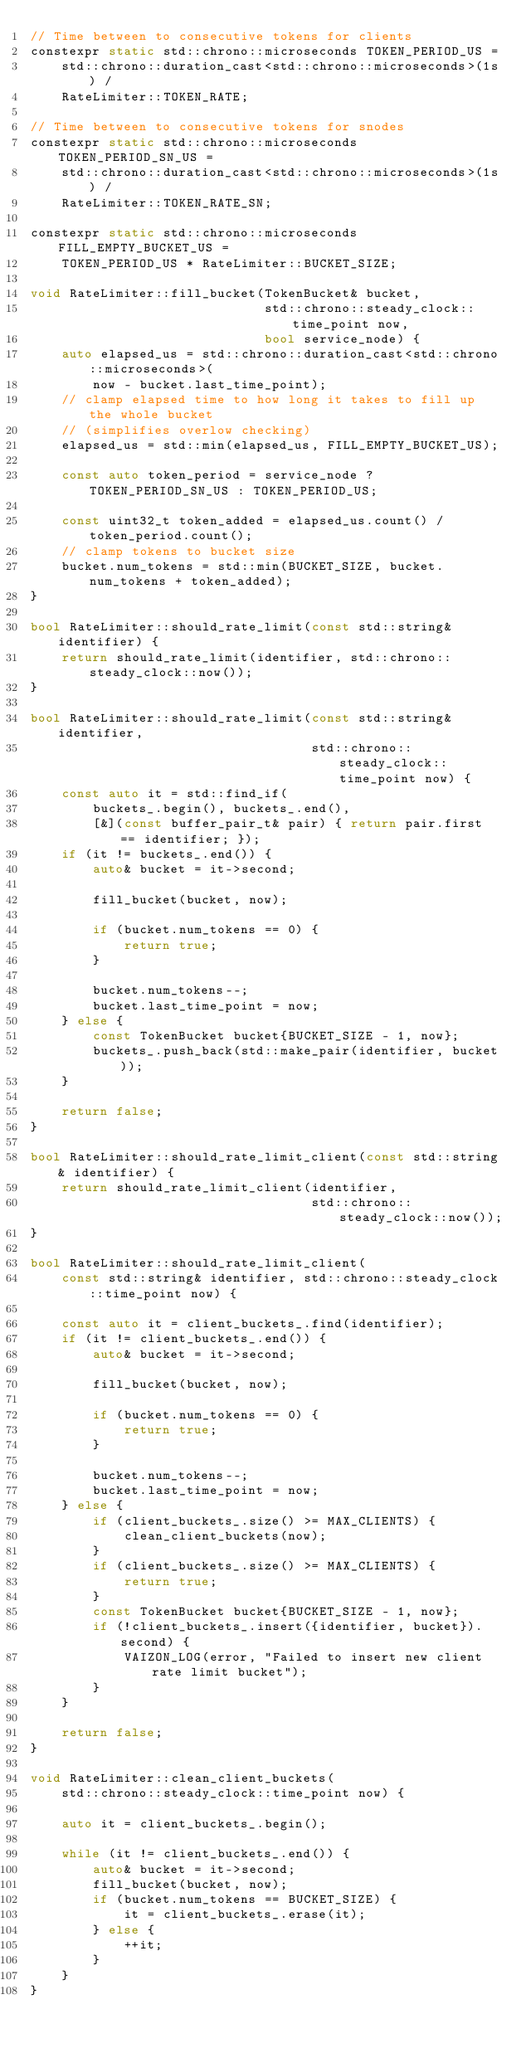Convert code to text. <code><loc_0><loc_0><loc_500><loc_500><_C++_>// Time between to consecutive tokens for clients
constexpr static std::chrono::microseconds TOKEN_PERIOD_US =
    std::chrono::duration_cast<std::chrono::microseconds>(1s) /
    RateLimiter::TOKEN_RATE;

// Time between to consecutive tokens for snodes
constexpr static std::chrono::microseconds TOKEN_PERIOD_SN_US =
    std::chrono::duration_cast<std::chrono::microseconds>(1s) /
    RateLimiter::TOKEN_RATE_SN;

constexpr static std::chrono::microseconds FILL_EMPTY_BUCKET_US =
    TOKEN_PERIOD_US * RateLimiter::BUCKET_SIZE;

void RateLimiter::fill_bucket(TokenBucket& bucket,
                              std::chrono::steady_clock::time_point now,
                              bool service_node) {
    auto elapsed_us = std::chrono::duration_cast<std::chrono::microseconds>(
        now - bucket.last_time_point);
    // clamp elapsed time to how long it takes to fill up the whole bucket
    // (simplifies overlow checking)
    elapsed_us = std::min(elapsed_us, FILL_EMPTY_BUCKET_US);

    const auto token_period = service_node ? TOKEN_PERIOD_SN_US : TOKEN_PERIOD_US;

    const uint32_t token_added = elapsed_us.count() / token_period.count();
    // clamp tokens to bucket size
    bucket.num_tokens = std::min(BUCKET_SIZE, bucket.num_tokens + token_added);
}

bool RateLimiter::should_rate_limit(const std::string& identifier) {
    return should_rate_limit(identifier, std::chrono::steady_clock::now());
}

bool RateLimiter::should_rate_limit(const std::string& identifier,
                                    std::chrono::steady_clock::time_point now) {
    const auto it = std::find_if(
        buckets_.begin(), buckets_.end(),
        [&](const buffer_pair_t& pair) { return pair.first == identifier; });
    if (it != buckets_.end()) {
        auto& bucket = it->second;

        fill_bucket(bucket, now);

        if (bucket.num_tokens == 0) {
            return true;
        }

        bucket.num_tokens--;
        bucket.last_time_point = now;
    } else {
        const TokenBucket bucket{BUCKET_SIZE - 1, now};
        buckets_.push_back(std::make_pair(identifier, bucket));
    }

    return false;
}

bool RateLimiter::should_rate_limit_client(const std::string& identifier) {
    return should_rate_limit_client(identifier,
                                    std::chrono::steady_clock::now());
}

bool RateLimiter::should_rate_limit_client(
    const std::string& identifier, std::chrono::steady_clock::time_point now) {

    const auto it = client_buckets_.find(identifier);
    if (it != client_buckets_.end()) {
        auto& bucket = it->second;

        fill_bucket(bucket, now);

        if (bucket.num_tokens == 0) {
            return true;
        }

        bucket.num_tokens--;
        bucket.last_time_point = now;
    } else {
        if (client_buckets_.size() >= MAX_CLIENTS) {
            clean_client_buckets(now);
        }
        if (client_buckets_.size() >= MAX_CLIENTS) {
            return true;
        }
        const TokenBucket bucket{BUCKET_SIZE - 1, now};
        if (!client_buckets_.insert({identifier, bucket}).second) {
            VAIZON_LOG(error, "Failed to insert new client rate limit bucket");
        }
    }

    return false;
}

void RateLimiter::clean_client_buckets(
    std::chrono::steady_clock::time_point now) {

    auto it = client_buckets_.begin();

    while (it != client_buckets_.end()) {
        auto& bucket = it->second;
        fill_bucket(bucket, now);
        if (bucket.num_tokens == BUCKET_SIZE) {
            it = client_buckets_.erase(it);
        } else {
            ++it;
        }
    }
}
</code> 